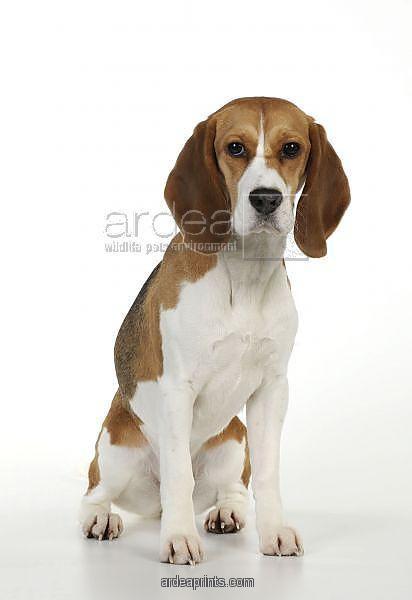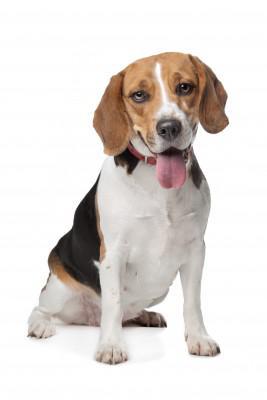The first image is the image on the left, the second image is the image on the right. Assess this claim about the two images: "both dogs are sitting with its front legs up.". Correct or not? Answer yes or no. Yes. 